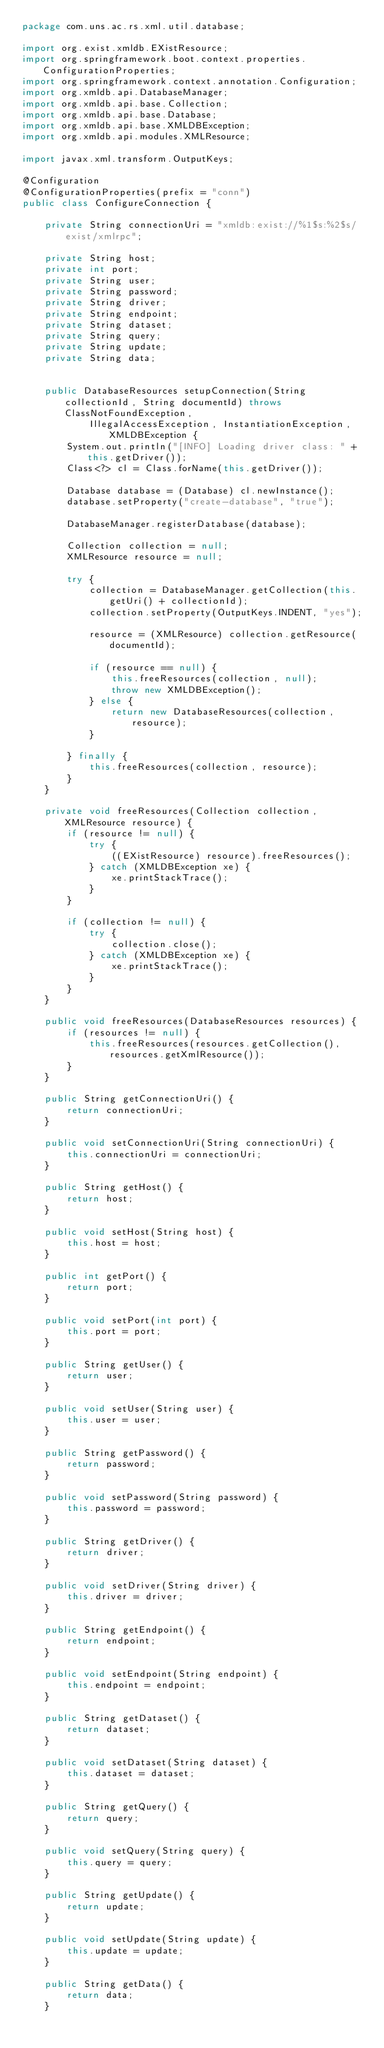Convert code to text. <code><loc_0><loc_0><loc_500><loc_500><_Java_>package com.uns.ac.rs.xml.util.database;

import org.exist.xmldb.EXistResource;
import org.springframework.boot.context.properties.ConfigurationProperties;
import org.springframework.context.annotation.Configuration;
import org.xmldb.api.DatabaseManager;
import org.xmldb.api.base.Collection;
import org.xmldb.api.base.Database;
import org.xmldb.api.base.XMLDBException;
import org.xmldb.api.modules.XMLResource;

import javax.xml.transform.OutputKeys;

@Configuration
@ConfigurationProperties(prefix = "conn")
public class ConfigureConnection {

    private String connectionUri = "xmldb:exist://%1$s:%2$s/exist/xmlrpc";

    private String host;
    private int port;
    private String user;
    private String password;
    private String driver;
    private String endpoint;
    private String dataset;
    private String query;
    private String update;
    private String data;


    public DatabaseResources setupConnection(String collectionId, String documentId) throws ClassNotFoundException,
            IllegalAccessException, InstantiationException, XMLDBException {
        System.out.println("[INFO] Loading driver class: " + this.getDriver());
        Class<?> cl = Class.forName(this.getDriver());

        Database database = (Database) cl.newInstance();
        database.setProperty("create-database", "true");

        DatabaseManager.registerDatabase(database);

        Collection collection = null;
        XMLResource resource = null;

        try {
            collection = DatabaseManager.getCollection(this.getUri() + collectionId);
            collection.setProperty(OutputKeys.INDENT, "yes");

            resource = (XMLResource) collection.getResource(documentId);

            if (resource == null) {
                this.freeResources(collection, null);
                throw new XMLDBException();
            } else {
                return new DatabaseResources(collection, resource);
            }

        } finally {
            this.freeResources(collection, resource);
        }
    }

    private void freeResources(Collection collection, XMLResource resource) {
        if (resource != null) {
            try {
                ((EXistResource) resource).freeResources();
            } catch (XMLDBException xe) {
                xe.printStackTrace();
            }
        }

        if (collection != null) {
            try {
                collection.close();
            } catch (XMLDBException xe) {
                xe.printStackTrace();
            }
        }
    }

    public void freeResources(DatabaseResources resources) {
        if (resources != null) {
            this.freeResources(resources.getCollection(), resources.getXmlResource());
        }
    }

    public String getConnectionUri() {
        return connectionUri;
    }

    public void setConnectionUri(String connectionUri) {
        this.connectionUri = connectionUri;
    }

    public String getHost() {
        return host;
    }

    public void setHost(String host) {
        this.host = host;
    }

    public int getPort() {
        return port;
    }

    public void setPort(int port) {
        this.port = port;
    }

    public String getUser() {
        return user;
    }

    public void setUser(String user) {
        this.user = user;
    }

    public String getPassword() {
        return password;
    }

    public void setPassword(String password) {
        this.password = password;
    }

    public String getDriver() {
        return driver;
    }

    public void setDriver(String driver) {
        this.driver = driver;
    }

    public String getEndpoint() {
        return endpoint;
    }

    public void setEndpoint(String endpoint) {
        this.endpoint = endpoint;
    }

    public String getDataset() {
        return dataset;
    }

    public void setDataset(String dataset) {
        this.dataset = dataset;
    }

    public String getQuery() {
        return query;
    }

    public void setQuery(String query) {
        this.query = query;
    }

    public String getUpdate() {
        return update;
    }

    public void setUpdate(String update) {
        this.update = update;
    }

    public String getData() {
        return data;
    }
</code> 